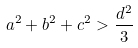<formula> <loc_0><loc_0><loc_500><loc_500>a ^ { 2 } + b ^ { 2 } + c ^ { 2 } > \frac { d ^ { 2 } } { 3 }</formula> 